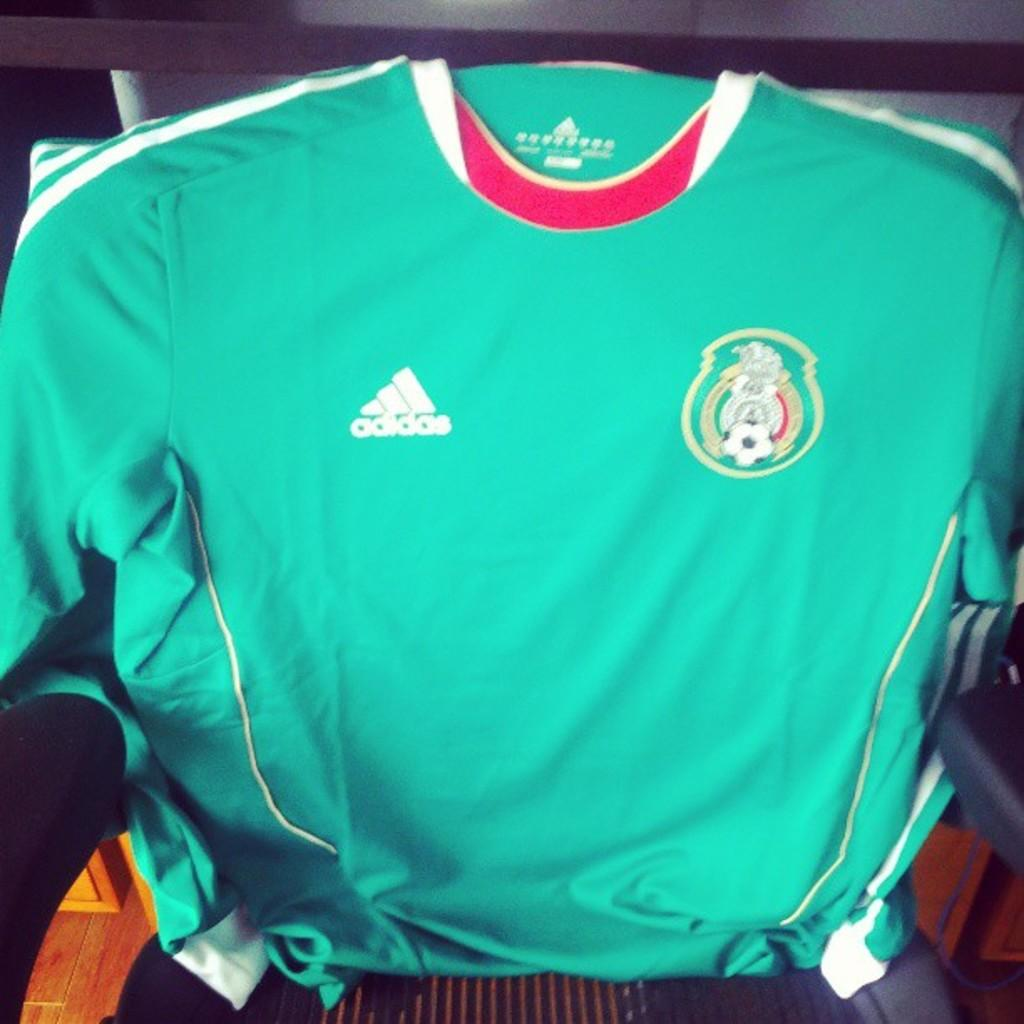Provide a one-sentence caption for the provided image. A Mexico jersey with the name Adidas on it. 